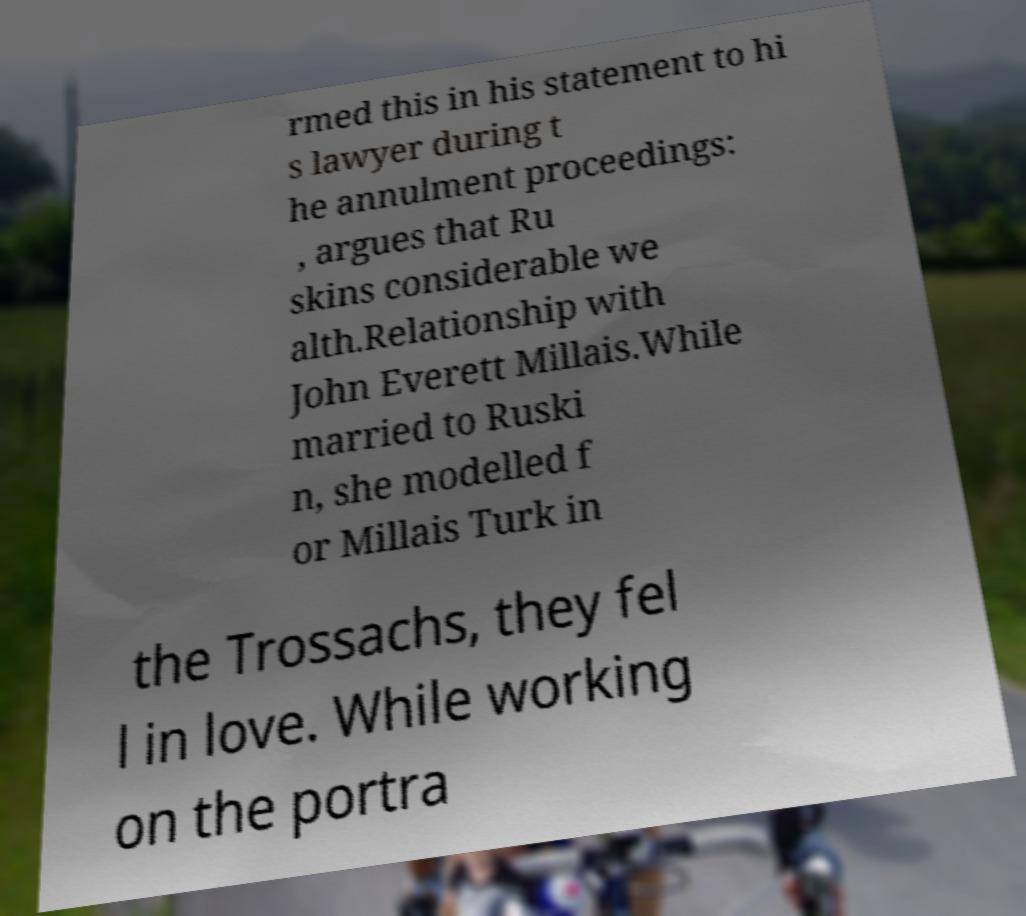There's text embedded in this image that I need extracted. Can you transcribe it verbatim? rmed this in his statement to hi s lawyer during t he annulment proceedings: , argues that Ru skins considerable we alth.Relationship with John Everett Millais.While married to Ruski n, she modelled f or Millais Turk in the Trossachs, they fel l in love. While working on the portra 